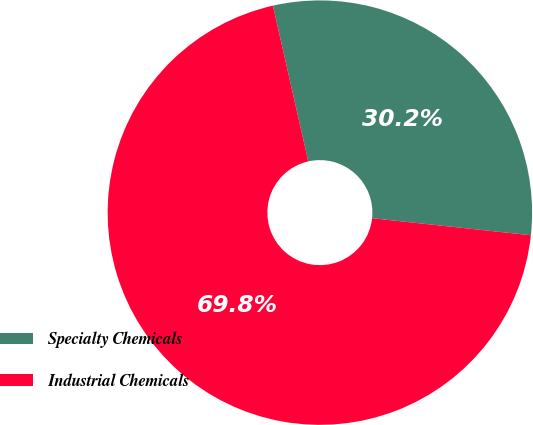Convert chart to OTSL. <chart><loc_0><loc_0><loc_500><loc_500><pie_chart><fcel>Specialty Chemicals<fcel>Industrial Chemicals<nl><fcel>30.25%<fcel>69.75%<nl></chart> 